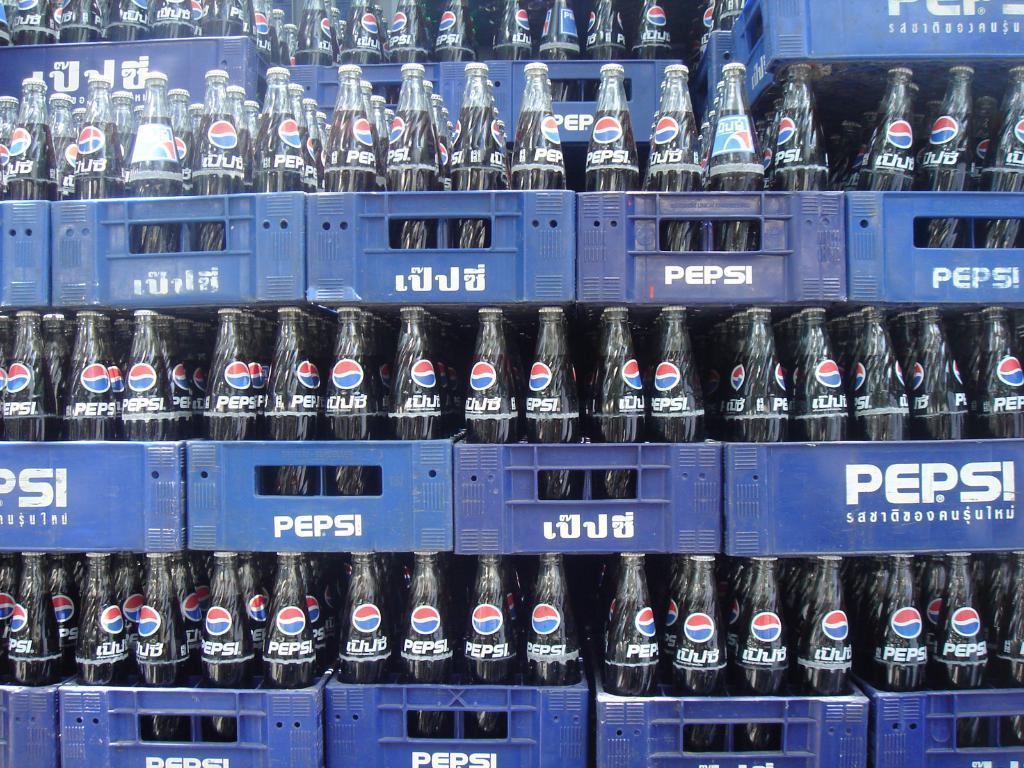Could you give a brief overview of what you see in this image? In this image, I can see the pepsi bottles with closed metal caps. These bottles are placed in the blue color baskets. 